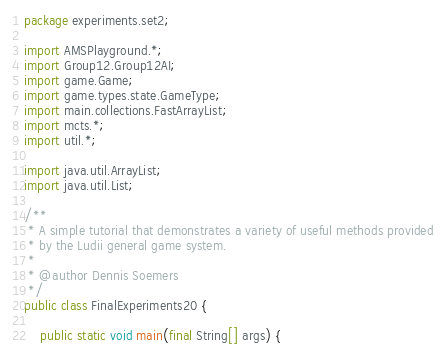Convert code to text. <code><loc_0><loc_0><loc_500><loc_500><_Java_>package experiments.set2;

import AMSPlayground.*;
import Group12.Group12AI;
import game.Game;
import game.types.state.GameType;
import main.collections.FastArrayList;
import mcts.*;
import util.*;

import java.util.ArrayList;
import java.util.List;

/**
 * A simple tutorial that demonstrates a variety of useful methods provided
 * by the Ludii general game system.
 *
 * @author Dennis Soemers
 */
public class FinalExperiments20 {

    public static void main(final String[] args) {</code> 